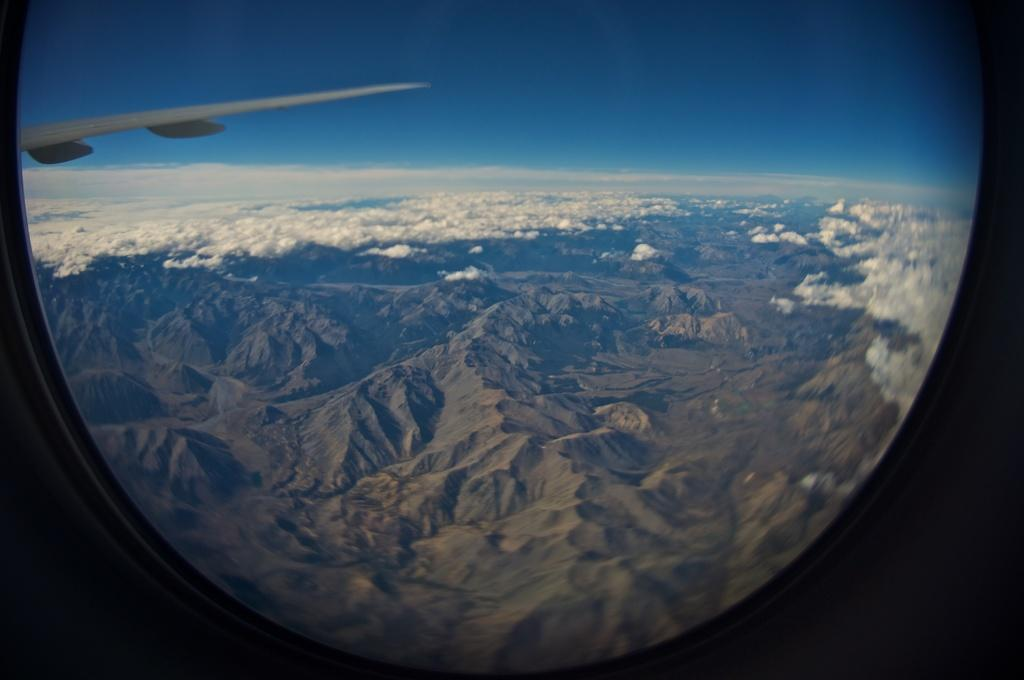What type of vehicle is partially visible in the image? There is a part of an aircraft in the image. What can be seen in the distance behind the aircraft? Mountains are visible in the background of the image. What is present in the sky in the background of the image? Clouds are present in the sky in the background of the image. Can you see a snake slithering across the aircraft in the image? There is no snake present in the image; it only features a part of an aircraft, mountains in the background, and clouds in the sky. 